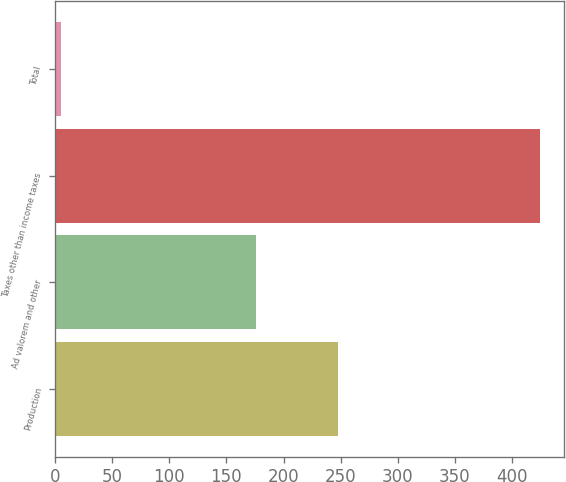Convert chart. <chart><loc_0><loc_0><loc_500><loc_500><bar_chart><fcel>Production<fcel>Ad valorem and other<fcel>Taxes other than income taxes<fcel>Total<nl><fcel>248<fcel>176<fcel>424<fcel>5.1<nl></chart> 